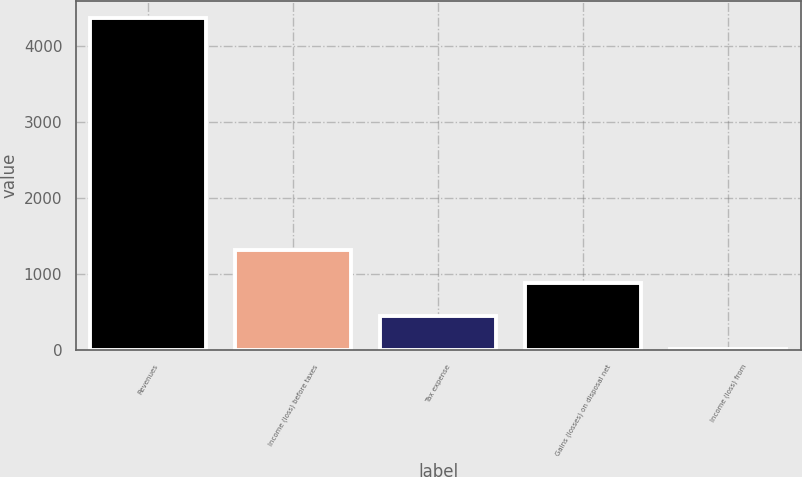<chart> <loc_0><loc_0><loc_500><loc_500><bar_chart><fcel>Revenues<fcel>Income (loss) before taxes<fcel>Tax expense<fcel>Gains (losses) on disposal net<fcel>Income (loss) from<nl><fcel>4367<fcel>1320.6<fcel>450.2<fcel>885.4<fcel>15<nl></chart> 